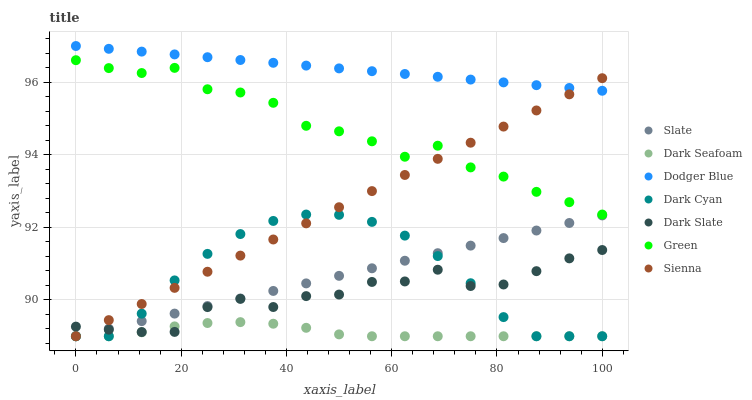Does Dark Seafoam have the minimum area under the curve?
Answer yes or no. Yes. Does Dodger Blue have the maximum area under the curve?
Answer yes or no. Yes. Does Sienna have the minimum area under the curve?
Answer yes or no. No. Does Sienna have the maximum area under the curve?
Answer yes or no. No. Is Slate the smoothest?
Answer yes or no. Yes. Is Green the roughest?
Answer yes or no. Yes. Is Sienna the smoothest?
Answer yes or no. No. Is Sienna the roughest?
Answer yes or no. No. Does Slate have the lowest value?
Answer yes or no. Yes. Does Dark Slate have the lowest value?
Answer yes or no. No. Does Dodger Blue have the highest value?
Answer yes or no. Yes. Does Sienna have the highest value?
Answer yes or no. No. Is Green less than Dodger Blue?
Answer yes or no. Yes. Is Dodger Blue greater than Dark Slate?
Answer yes or no. Yes. Does Dark Seafoam intersect Dark Cyan?
Answer yes or no. Yes. Is Dark Seafoam less than Dark Cyan?
Answer yes or no. No. Is Dark Seafoam greater than Dark Cyan?
Answer yes or no. No. Does Green intersect Dodger Blue?
Answer yes or no. No. 